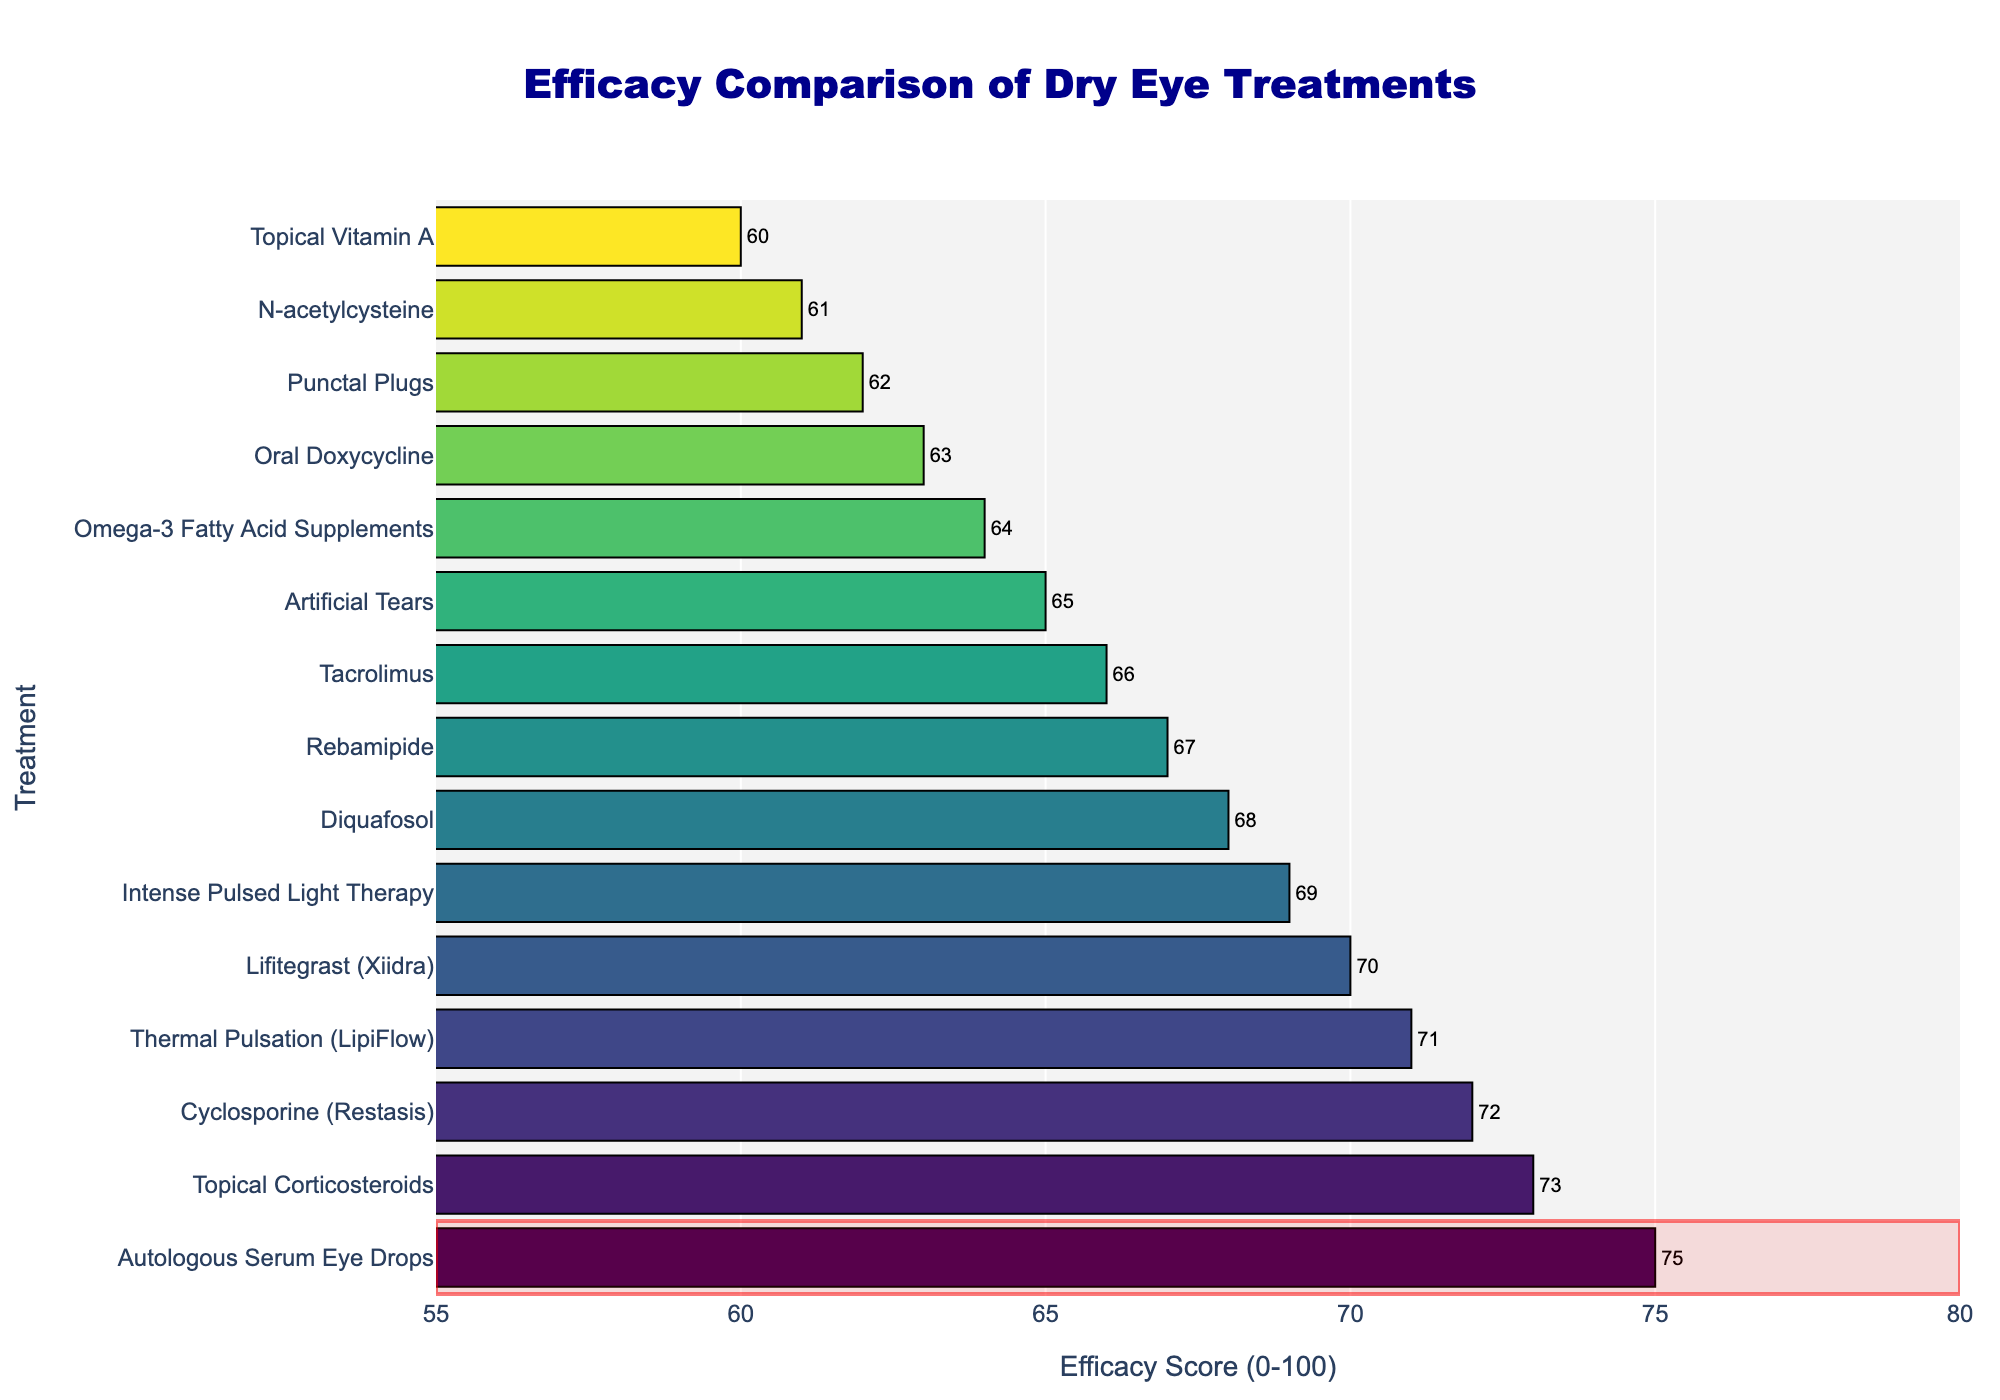Which treatment has the highest efficacy score? The Autologous Serum Eye Drops bar extends the farthest to the right, indicating the highest efficacy score.
Answer: Autologous Serum Eye Drops Which treatment has a lower efficacy, Artificial Tears or Punctal Plugs? By observing the length of the bars, Punctal Plugs is shorter than Artificial Tears, indicating lower efficacy.
Answer: Punctal Plugs What's the difference in efficacy score between Cyclosporine (Restasis) and Lifitegrast (Xiidra)? Cyclosporine (Restasis) has an efficacy score of 72 and Lifitegrast (Xiidra) has 70. Subtracting 70 from 72 gives the difference.
Answer: 2 Which treatment falls in the middle when sorted by efficacy score? When ordered by efficacy, Thermal Pulsation (LipiFlow) is positioned in the middle of the list.
Answer: Thermal Pulsation (LipiFlow) How many treatments have an efficacy score of 70 or higher? Count the bars with efficacy scores of 70 or higher: Cyclosporine (Restasis), Lifitegrast (Xiidra), Autologous Serum Eye Drops, Thermal Pulsation (LipiFlow), and Topical Corticosteroids, totaling 5.
Answer: 5 Which treatment has the lowest efficacy score? The Topical Vitamin A bar is the shortest, indicating the lowest efficacy score of 60.
Answer: Topical Vitamin A What is the range of efficacy scores in the figure? The highest score is 75 (Autologous Serum Eye Drops) and the lowest score is 60 (Topical Vitamin A), so the range is 75 - 60.
Answer: 15 Compare the efficacy score of Rebamipide with that of Thermal Pulsation (LipiFlow). Rebamipide has an efficacy score of 67, while Thermal Pulsation (LipiFlow) has a score of 71; Thermal Pulsation (LipiFlow) is higher.
Answer: Thermal Pulsation (LipiFlow) What's the average efficacy score of N-acetylcysteine, Topical Vitamin A, and Oral Doxycycline? Their scores are 61, 60, and 63. The sum is 184 and the average is 184 / 3.
Answer: 61.3 